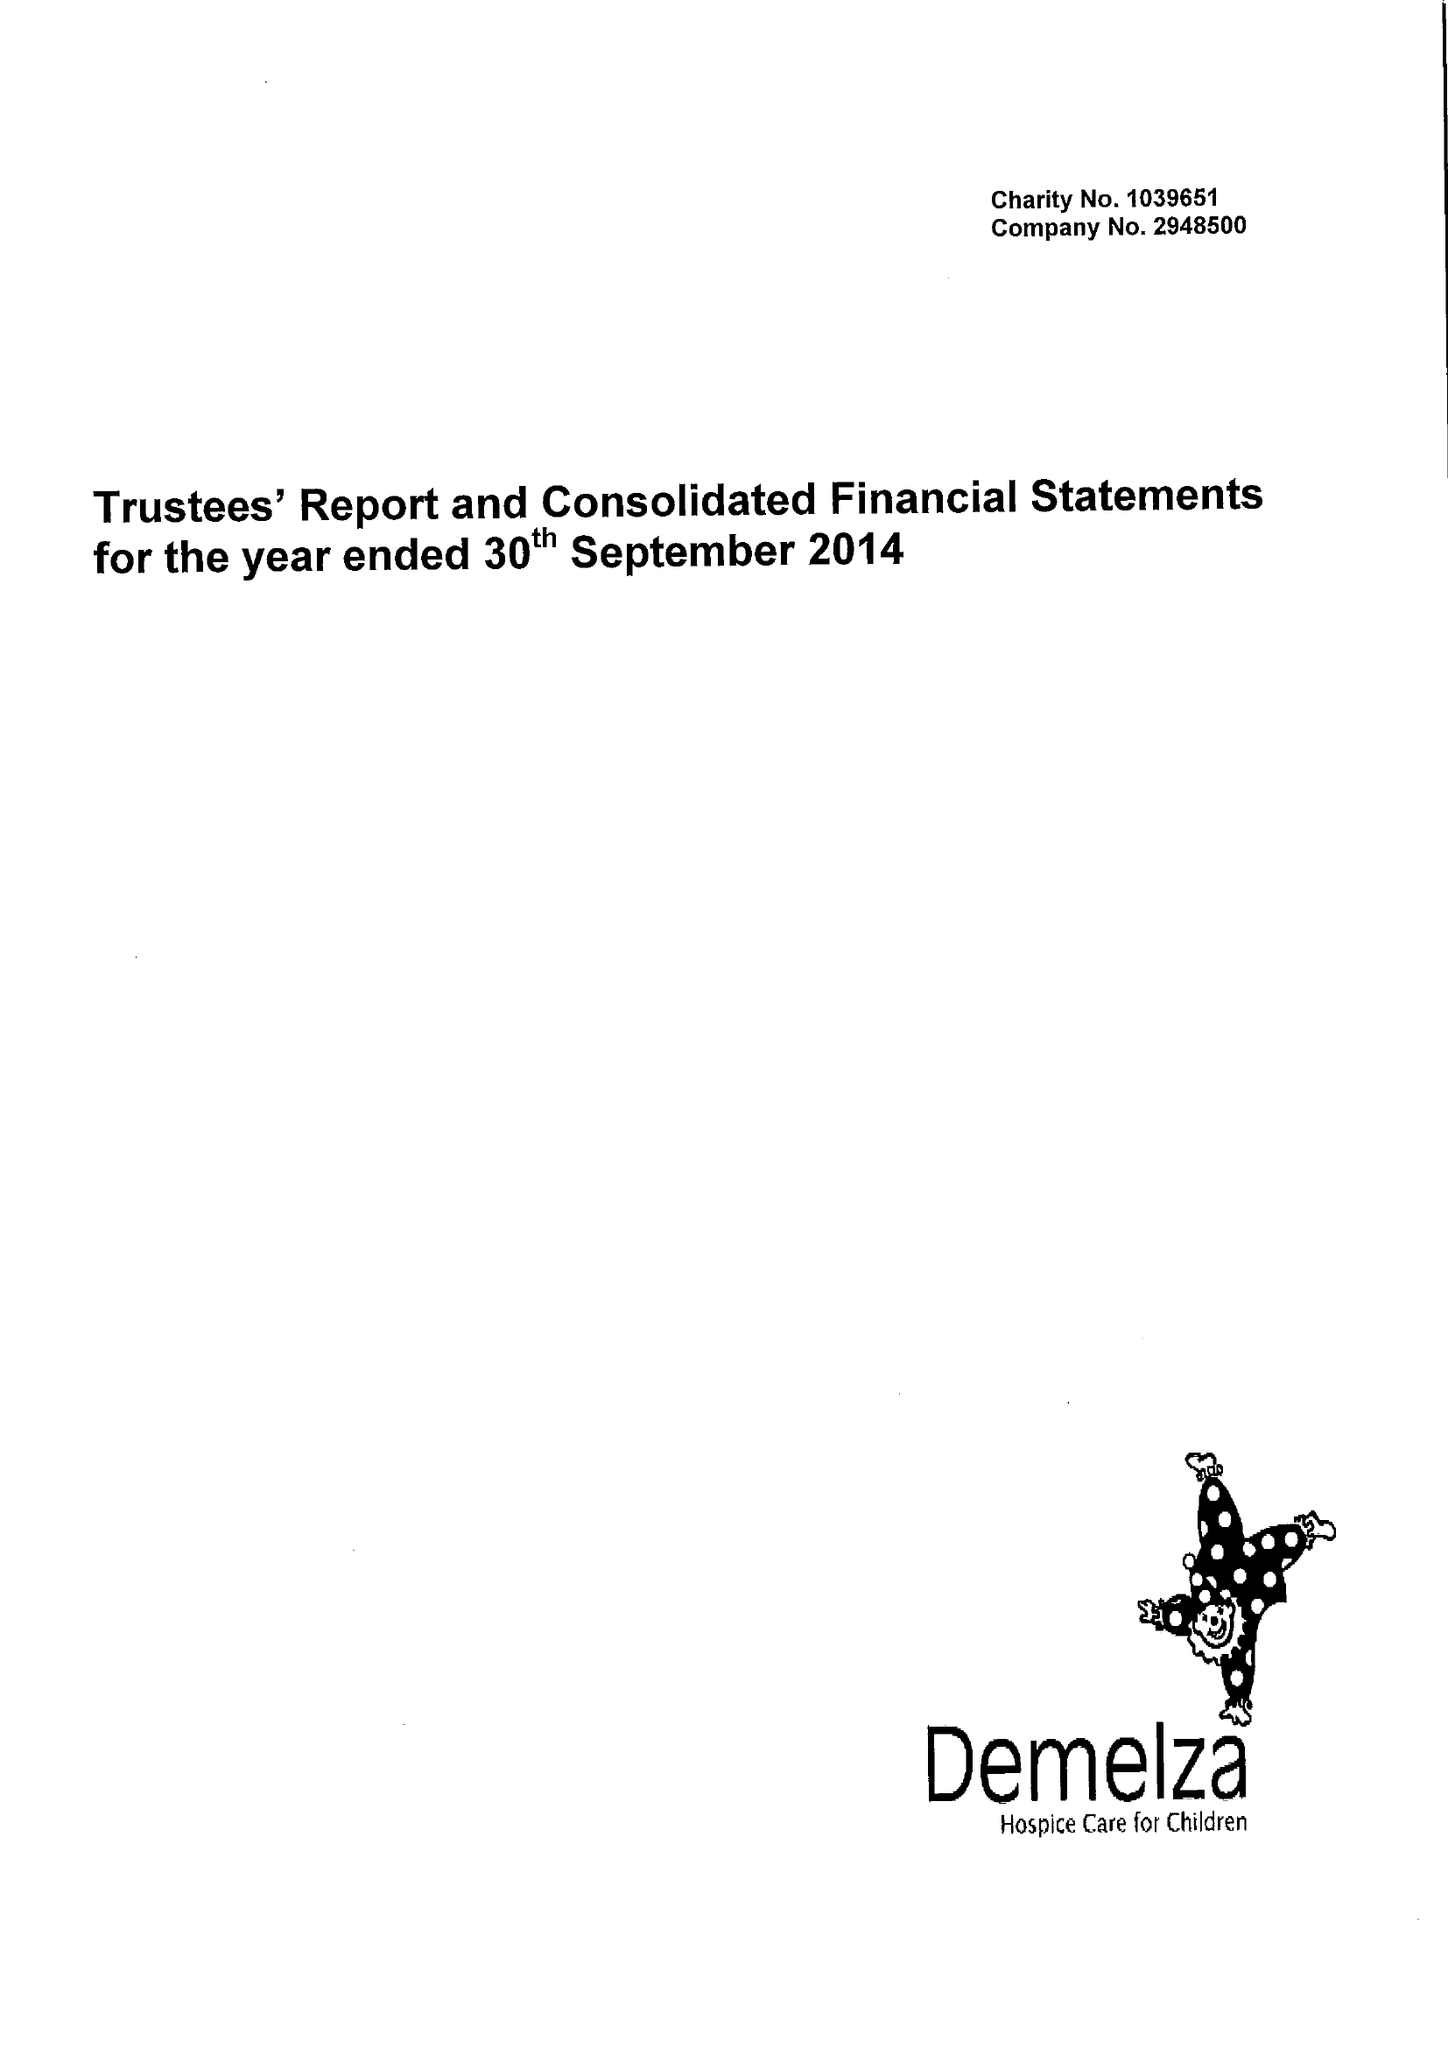What is the value for the address__postcode?
Answer the question using a single word or phrase. ME9 8DZ 